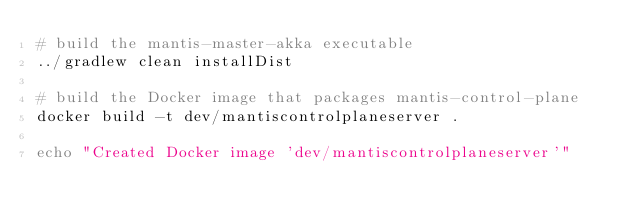Convert code to text. <code><loc_0><loc_0><loc_500><loc_500><_Bash_># build the mantis-master-akka executable
../gradlew clean installDist

# build the Docker image that packages mantis-control-plane
docker build -t dev/mantiscontrolplaneserver .

echo "Created Docker image 'dev/mantiscontrolplaneserver'"
</code> 